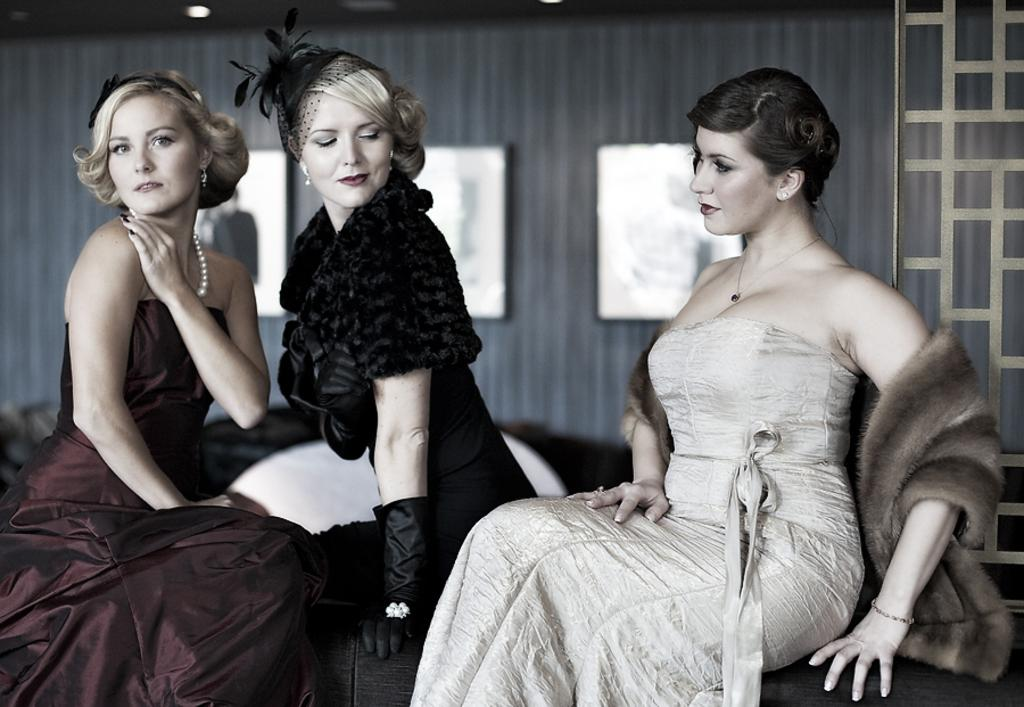How many women are sitting in the image? There are three women sitting in the image. What can be seen on the wall in the background of the image? There are boards on a wall in the background of the image. What is visible above the women in the image? There is a roof visible in the background of the image. What type of lighting is present on the roof? There are ceiling lights on the roof. What type of boats are visible in the image? There are no boats present in the image. How does the image demonstrate respect for the environment? The image does not demonstrate respect for the environment, as it only shows three women sitting and the surrounding elements. 